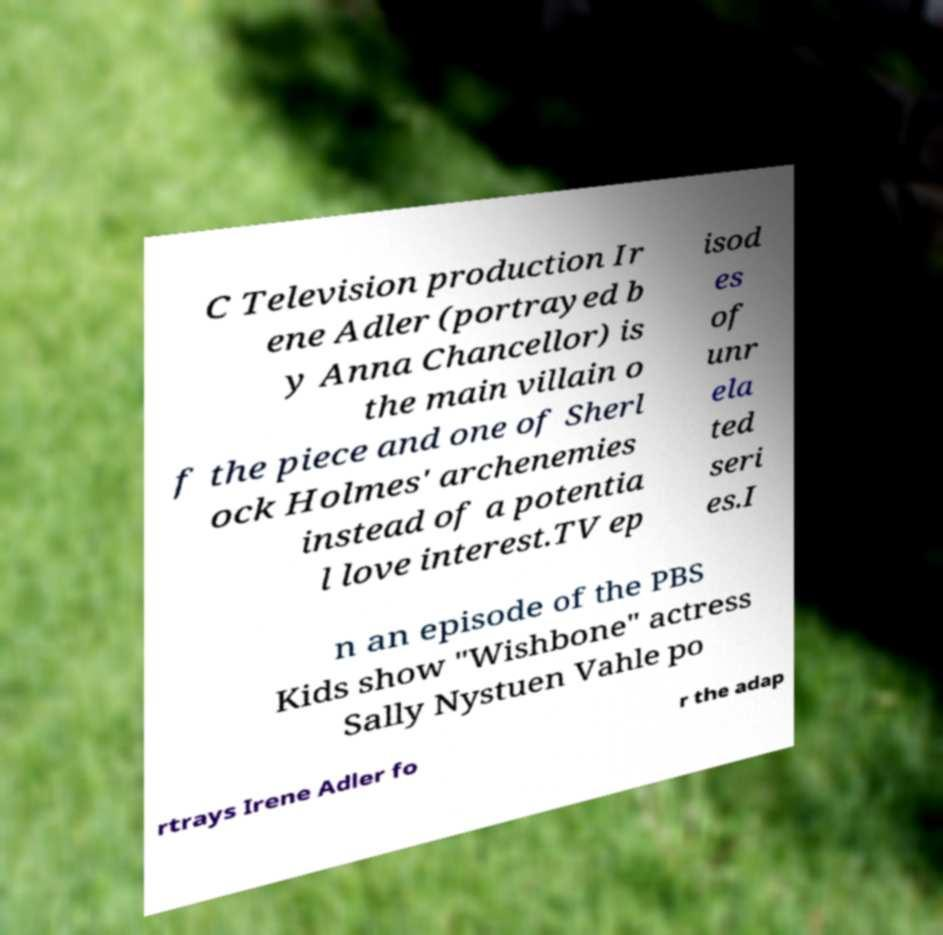Could you extract and type out the text from this image? C Television production Ir ene Adler (portrayed b y Anna Chancellor) is the main villain o f the piece and one of Sherl ock Holmes' archenemies instead of a potentia l love interest.TV ep isod es of unr ela ted seri es.I n an episode of the PBS Kids show "Wishbone" actress Sally Nystuen Vahle po rtrays Irene Adler fo r the adap 